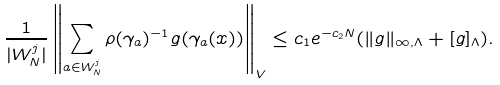<formula> <loc_0><loc_0><loc_500><loc_500>\frac { 1 } { | W _ { N } ^ { j } | } \left \| \sum _ { a \in W _ { N } ^ { j } } \rho ( \gamma _ { a } ) ^ { - 1 } g ( \gamma _ { a } ( x ) ) \right \| _ { V } \leq c _ { 1 } e ^ { - c _ { 2 } N } ( \| g \| _ { \infty , \Lambda } + [ g ] _ { \Lambda } ) .</formula> 